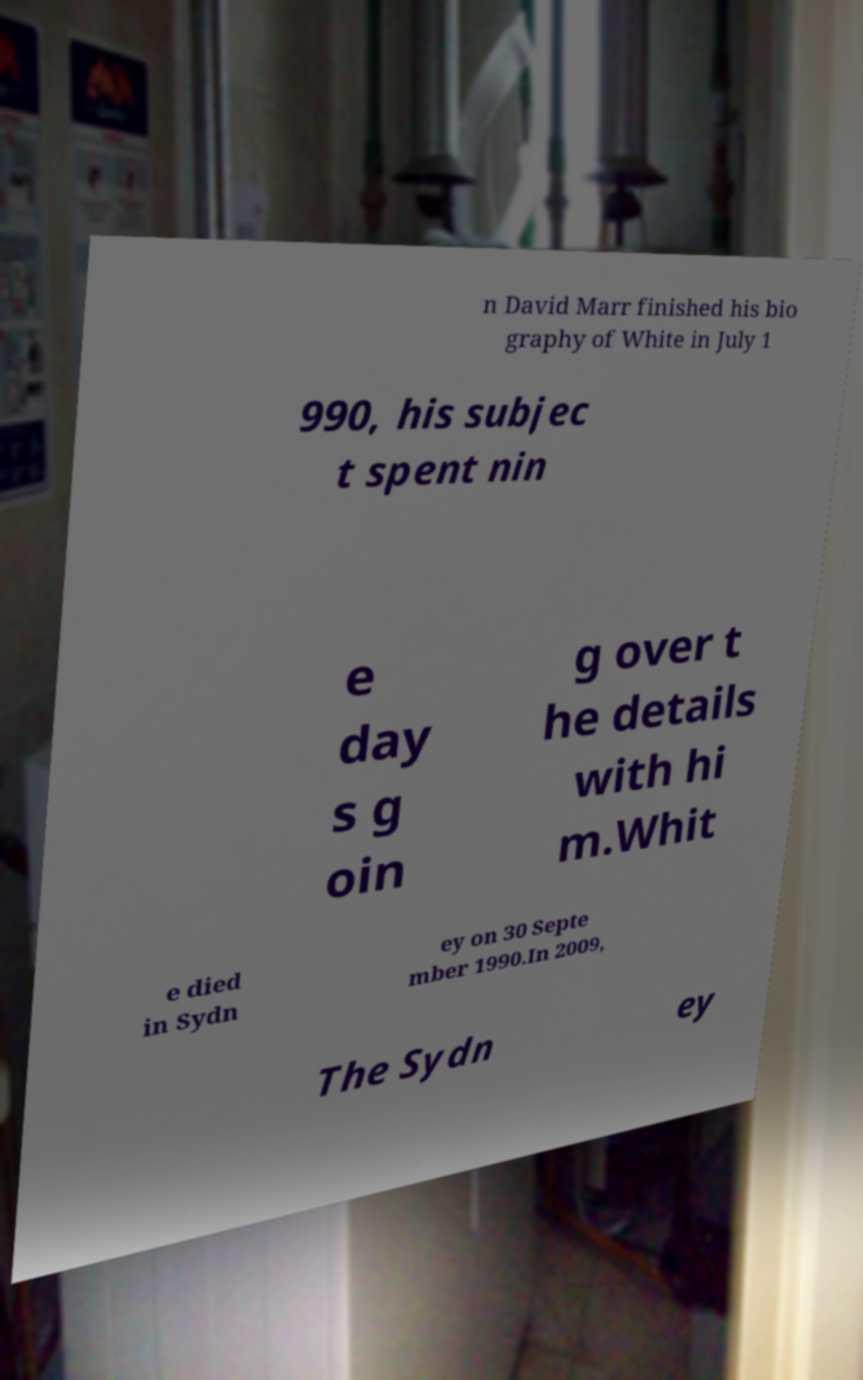There's text embedded in this image that I need extracted. Can you transcribe it verbatim? n David Marr finished his bio graphy of White in July 1 990, his subjec t spent nin e day s g oin g over t he details with hi m.Whit e died in Sydn ey on 30 Septe mber 1990.In 2009, The Sydn ey 